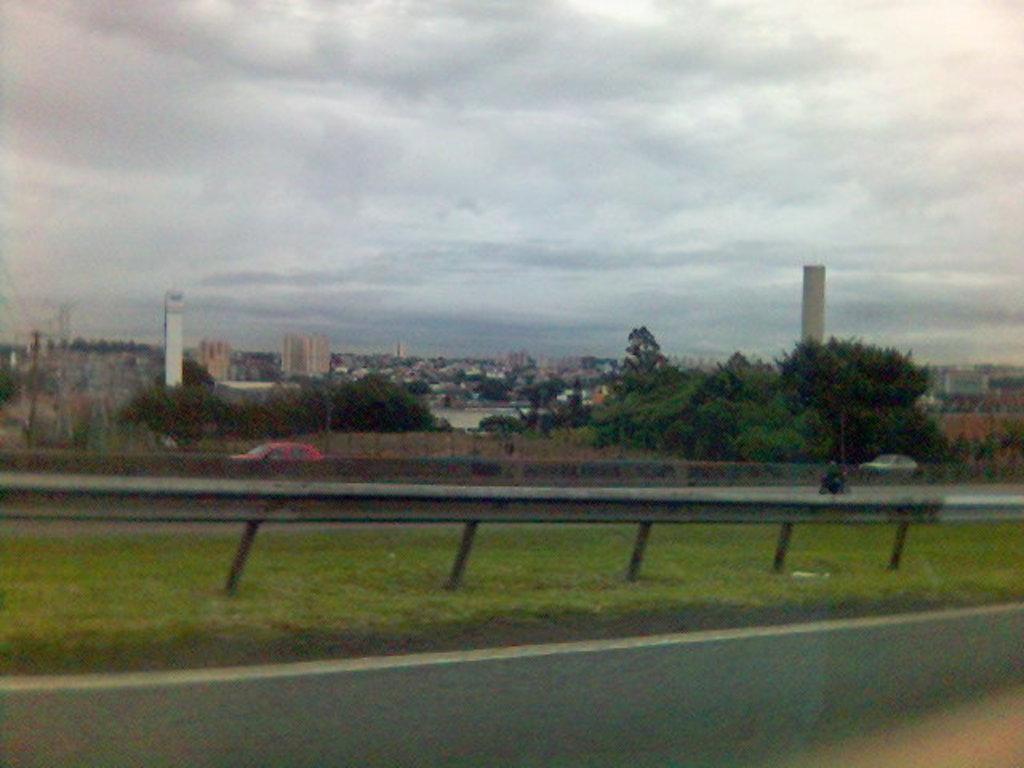Describe this image in one or two sentences. In the image we can see there is a road and there is ground covered with grass. There are cars parked on the road and there are lot of trees. Behind there are buildings and there is a cloudy sky. 